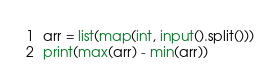Convert code to text. <code><loc_0><loc_0><loc_500><loc_500><_Python_>arr = list(map(int, input().split()))
print(max(arr) - min(arr))</code> 